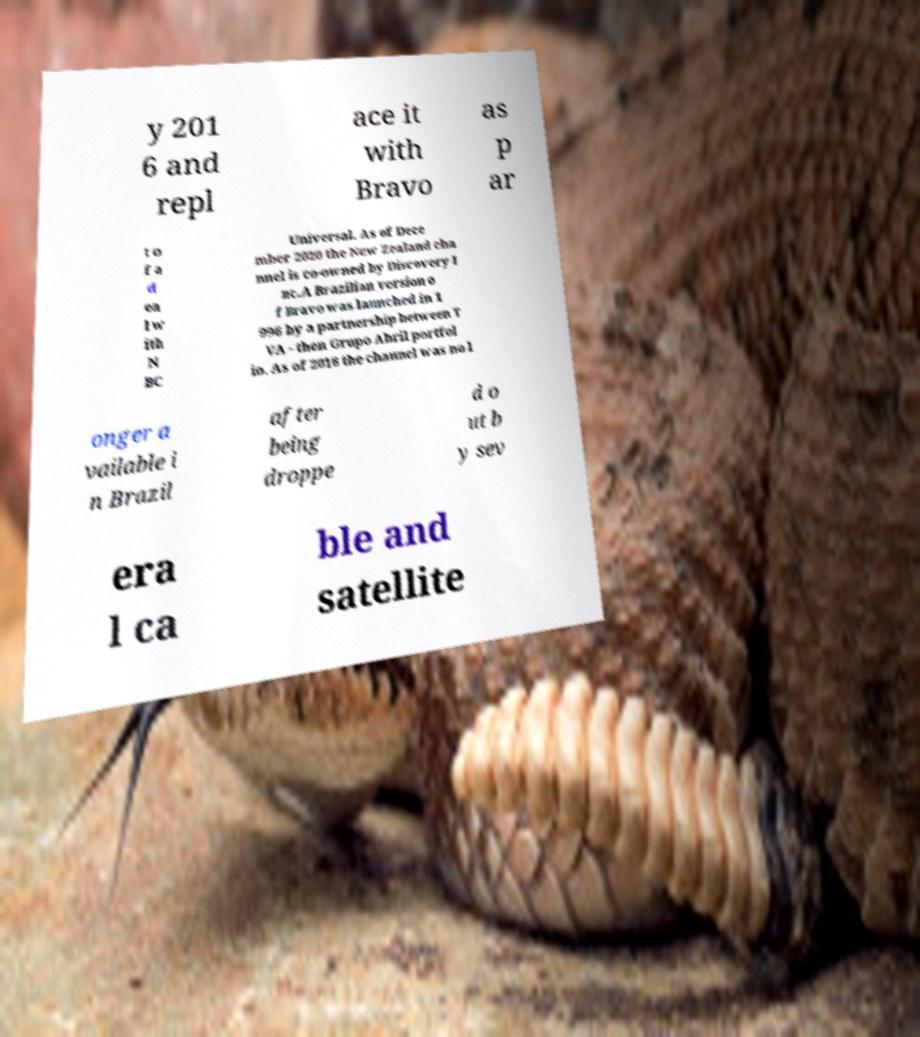I need the written content from this picture converted into text. Can you do that? y 201 6 and repl ace it with Bravo as p ar t o f a d ea l w ith N BC Universal. As of Dece mber 2020 the New Zealand cha nnel is co-owned by Discovery I nc.A Brazilian version o f Bravo was launched in 1 996 by a partnership between T VA - then Grupo Abril portfol io. As of 2016 the channel was no l onger a vailable i n Brazil after being droppe d o ut b y sev era l ca ble and satellite 